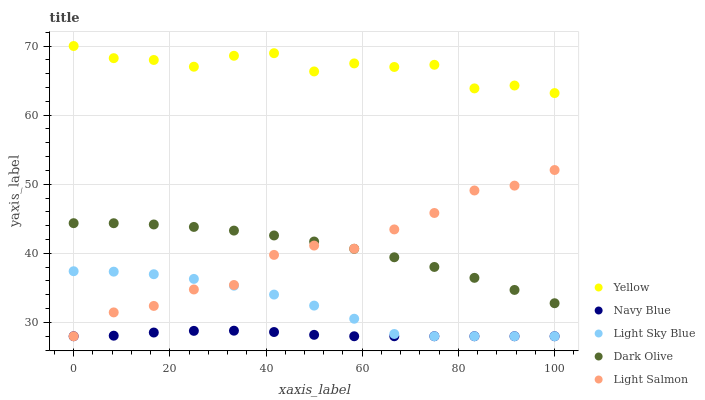Does Navy Blue have the minimum area under the curve?
Answer yes or no. Yes. Does Yellow have the maximum area under the curve?
Answer yes or no. Yes. Does Light Salmon have the minimum area under the curve?
Answer yes or no. No. Does Light Salmon have the maximum area under the curve?
Answer yes or no. No. Is Navy Blue the smoothest?
Answer yes or no. Yes. Is Yellow the roughest?
Answer yes or no. Yes. Is Light Salmon the smoothest?
Answer yes or no. No. Is Light Salmon the roughest?
Answer yes or no. No. Does Navy Blue have the lowest value?
Answer yes or no. Yes. Does Yellow have the lowest value?
Answer yes or no. No. Does Yellow have the highest value?
Answer yes or no. Yes. Does Light Salmon have the highest value?
Answer yes or no. No. Is Light Sky Blue less than Dark Olive?
Answer yes or no. Yes. Is Yellow greater than Light Sky Blue?
Answer yes or no. Yes. Does Light Salmon intersect Dark Olive?
Answer yes or no. Yes. Is Light Salmon less than Dark Olive?
Answer yes or no. No. Is Light Salmon greater than Dark Olive?
Answer yes or no. No. Does Light Sky Blue intersect Dark Olive?
Answer yes or no. No. 